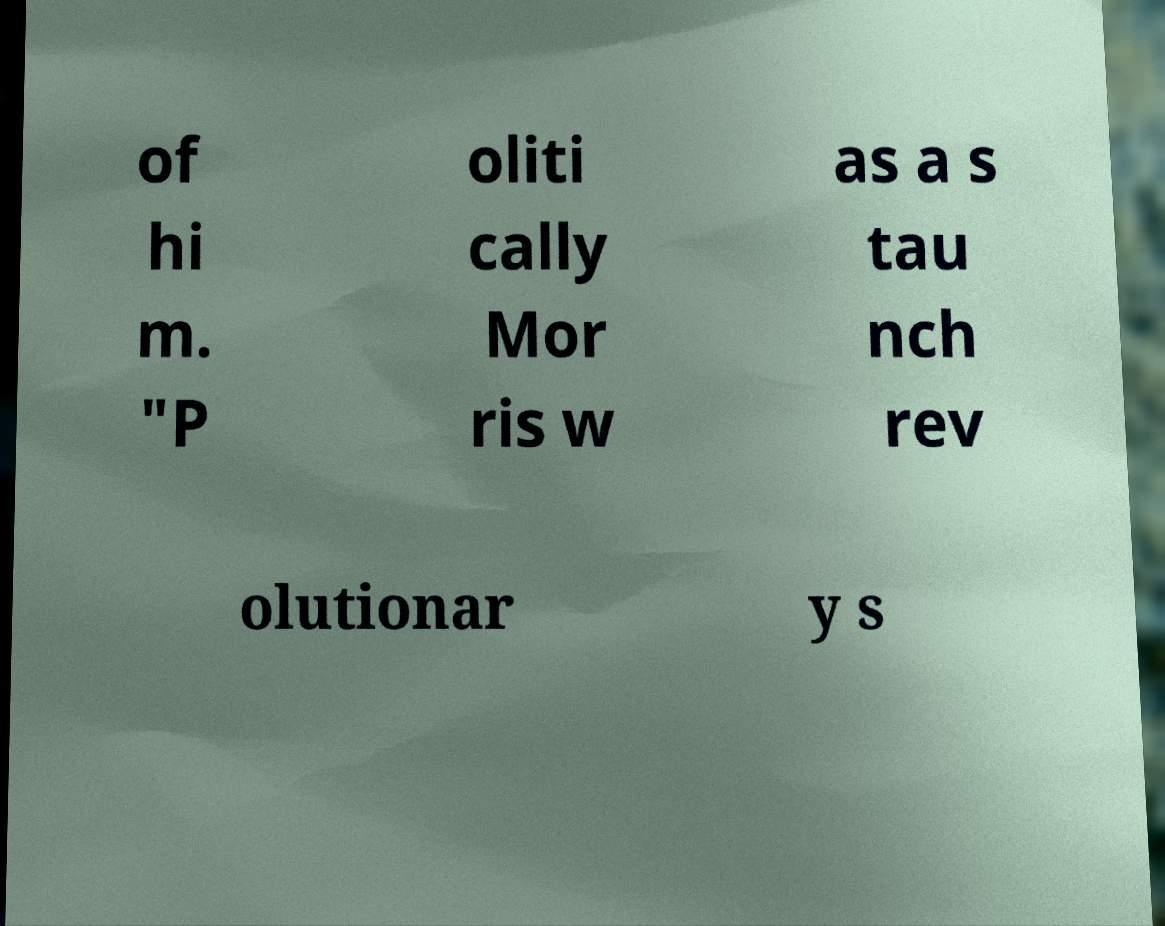Please read and relay the text visible in this image. What does it say? of hi m. "P oliti cally Mor ris w as a s tau nch rev olutionar y s 